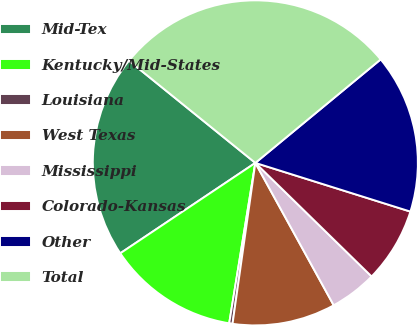Convert chart to OTSL. <chart><loc_0><loc_0><loc_500><loc_500><pie_chart><fcel>Mid-Tex<fcel>Kentucky/Mid-States<fcel>Louisiana<fcel>West Texas<fcel>Mississippi<fcel>Colorado-Kansas<fcel>Other<fcel>Total<nl><fcel>20.21%<fcel>13.04%<fcel>0.33%<fcel>10.25%<fcel>4.68%<fcel>7.47%<fcel>15.83%<fcel>28.19%<nl></chart> 